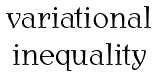<formula> <loc_0><loc_0><loc_500><loc_500>\begin{matrix} \text {variational} \\ \text {inequality} \end{matrix}</formula> 